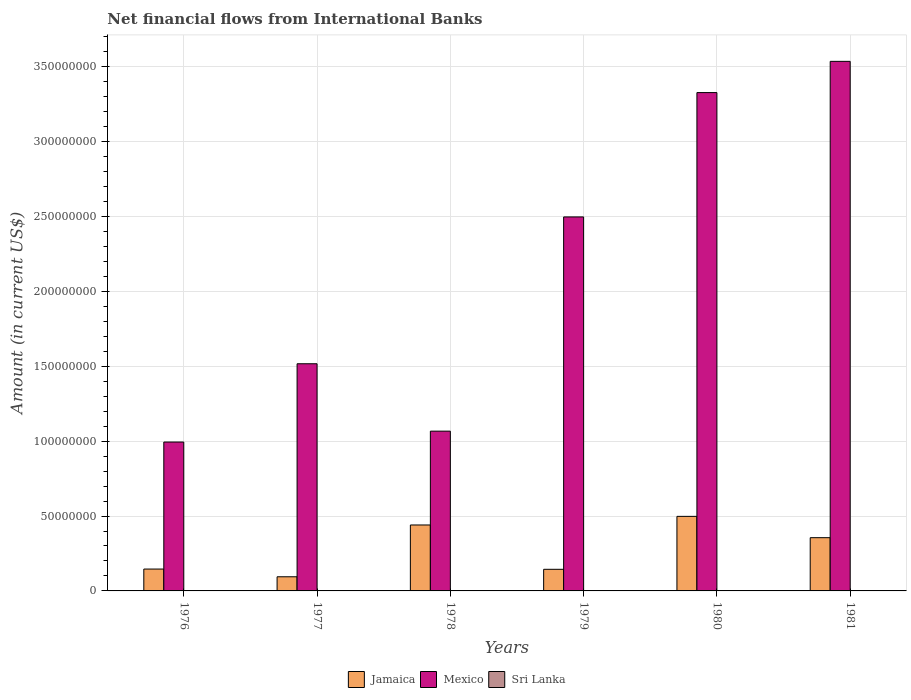How many groups of bars are there?
Make the answer very short. 6. Are the number of bars on each tick of the X-axis equal?
Keep it short and to the point. Yes. How many bars are there on the 4th tick from the right?
Offer a terse response. 2. What is the net financial aid flows in Sri Lanka in 1981?
Provide a short and direct response. 0. Across all years, what is the maximum net financial aid flows in Jamaica?
Keep it short and to the point. 4.98e+07. Across all years, what is the minimum net financial aid flows in Jamaica?
Keep it short and to the point. 9.44e+06. In which year was the net financial aid flows in Mexico maximum?
Provide a succinct answer. 1981. What is the total net financial aid flows in Mexico in the graph?
Make the answer very short. 1.29e+09. What is the difference between the net financial aid flows in Mexico in 1977 and that in 1980?
Offer a very short reply. -1.81e+08. What is the difference between the net financial aid flows in Mexico in 1976 and the net financial aid flows in Sri Lanka in 1980?
Give a very brief answer. 9.94e+07. What is the average net financial aid flows in Mexico per year?
Your answer should be very brief. 2.16e+08. In the year 1980, what is the difference between the net financial aid flows in Mexico and net financial aid flows in Jamaica?
Your answer should be compact. 2.83e+08. What is the ratio of the net financial aid flows in Mexico in 1979 to that in 1981?
Provide a short and direct response. 0.71. Is the net financial aid flows in Mexico in 1977 less than that in 1978?
Your response must be concise. No. Is the difference between the net financial aid flows in Mexico in 1977 and 1980 greater than the difference between the net financial aid flows in Jamaica in 1977 and 1980?
Ensure brevity in your answer.  No. What is the difference between the highest and the second highest net financial aid flows in Mexico?
Your response must be concise. 2.09e+07. What is the difference between the highest and the lowest net financial aid flows in Mexico?
Offer a very short reply. 2.54e+08. Is the sum of the net financial aid flows in Jamaica in 1977 and 1978 greater than the maximum net financial aid flows in Sri Lanka across all years?
Provide a succinct answer. Yes. Is it the case that in every year, the sum of the net financial aid flows in Sri Lanka and net financial aid flows in Jamaica is greater than the net financial aid flows in Mexico?
Offer a terse response. No. How many years are there in the graph?
Make the answer very short. 6. What is the difference between two consecutive major ticks on the Y-axis?
Make the answer very short. 5.00e+07. Does the graph contain any zero values?
Provide a succinct answer. Yes. Where does the legend appear in the graph?
Provide a succinct answer. Bottom center. What is the title of the graph?
Offer a terse response. Net financial flows from International Banks. Does "Congo (Democratic)" appear as one of the legend labels in the graph?
Your answer should be very brief. No. What is the Amount (in current US$) of Jamaica in 1976?
Provide a succinct answer. 1.46e+07. What is the Amount (in current US$) of Mexico in 1976?
Your answer should be compact. 9.94e+07. What is the Amount (in current US$) in Sri Lanka in 1976?
Give a very brief answer. 0. What is the Amount (in current US$) in Jamaica in 1977?
Offer a terse response. 9.44e+06. What is the Amount (in current US$) in Mexico in 1977?
Offer a very short reply. 1.52e+08. What is the Amount (in current US$) in Sri Lanka in 1977?
Your answer should be very brief. 0. What is the Amount (in current US$) of Jamaica in 1978?
Give a very brief answer. 4.40e+07. What is the Amount (in current US$) of Mexico in 1978?
Your response must be concise. 1.07e+08. What is the Amount (in current US$) of Jamaica in 1979?
Give a very brief answer. 1.44e+07. What is the Amount (in current US$) in Mexico in 1979?
Give a very brief answer. 2.50e+08. What is the Amount (in current US$) in Sri Lanka in 1979?
Provide a short and direct response. 0. What is the Amount (in current US$) of Jamaica in 1980?
Provide a short and direct response. 4.98e+07. What is the Amount (in current US$) of Mexico in 1980?
Provide a succinct answer. 3.33e+08. What is the Amount (in current US$) of Jamaica in 1981?
Give a very brief answer. 3.56e+07. What is the Amount (in current US$) in Mexico in 1981?
Give a very brief answer. 3.54e+08. What is the Amount (in current US$) of Sri Lanka in 1981?
Offer a terse response. 0. Across all years, what is the maximum Amount (in current US$) in Jamaica?
Your response must be concise. 4.98e+07. Across all years, what is the maximum Amount (in current US$) in Mexico?
Provide a short and direct response. 3.54e+08. Across all years, what is the minimum Amount (in current US$) of Jamaica?
Offer a very short reply. 9.44e+06. Across all years, what is the minimum Amount (in current US$) of Mexico?
Provide a short and direct response. 9.94e+07. What is the total Amount (in current US$) in Jamaica in the graph?
Make the answer very short. 1.68e+08. What is the total Amount (in current US$) of Mexico in the graph?
Provide a short and direct response. 1.29e+09. What is the difference between the Amount (in current US$) of Jamaica in 1976 and that in 1977?
Offer a very short reply. 5.15e+06. What is the difference between the Amount (in current US$) in Mexico in 1976 and that in 1977?
Keep it short and to the point. -5.23e+07. What is the difference between the Amount (in current US$) of Jamaica in 1976 and that in 1978?
Offer a very short reply. -2.94e+07. What is the difference between the Amount (in current US$) in Mexico in 1976 and that in 1978?
Keep it short and to the point. -7.27e+06. What is the difference between the Amount (in current US$) in Jamaica in 1976 and that in 1979?
Provide a succinct answer. 1.60e+05. What is the difference between the Amount (in current US$) of Mexico in 1976 and that in 1979?
Provide a short and direct response. -1.50e+08. What is the difference between the Amount (in current US$) of Jamaica in 1976 and that in 1980?
Provide a short and direct response. -3.52e+07. What is the difference between the Amount (in current US$) in Mexico in 1976 and that in 1980?
Your response must be concise. -2.33e+08. What is the difference between the Amount (in current US$) in Jamaica in 1976 and that in 1981?
Offer a terse response. -2.10e+07. What is the difference between the Amount (in current US$) of Mexico in 1976 and that in 1981?
Offer a very short reply. -2.54e+08. What is the difference between the Amount (in current US$) of Jamaica in 1977 and that in 1978?
Keep it short and to the point. -3.46e+07. What is the difference between the Amount (in current US$) of Mexico in 1977 and that in 1978?
Ensure brevity in your answer.  4.50e+07. What is the difference between the Amount (in current US$) in Jamaica in 1977 and that in 1979?
Make the answer very short. -4.99e+06. What is the difference between the Amount (in current US$) of Mexico in 1977 and that in 1979?
Your response must be concise. -9.80e+07. What is the difference between the Amount (in current US$) in Jamaica in 1977 and that in 1980?
Your answer should be compact. -4.03e+07. What is the difference between the Amount (in current US$) in Mexico in 1977 and that in 1980?
Provide a succinct answer. -1.81e+08. What is the difference between the Amount (in current US$) of Jamaica in 1977 and that in 1981?
Offer a very short reply. -2.61e+07. What is the difference between the Amount (in current US$) in Mexico in 1977 and that in 1981?
Give a very brief answer. -2.02e+08. What is the difference between the Amount (in current US$) of Jamaica in 1978 and that in 1979?
Offer a terse response. 2.96e+07. What is the difference between the Amount (in current US$) in Mexico in 1978 and that in 1979?
Your response must be concise. -1.43e+08. What is the difference between the Amount (in current US$) of Jamaica in 1978 and that in 1980?
Keep it short and to the point. -5.75e+06. What is the difference between the Amount (in current US$) of Mexico in 1978 and that in 1980?
Ensure brevity in your answer.  -2.26e+08. What is the difference between the Amount (in current US$) in Jamaica in 1978 and that in 1981?
Ensure brevity in your answer.  8.48e+06. What is the difference between the Amount (in current US$) of Mexico in 1978 and that in 1981?
Your answer should be very brief. -2.47e+08. What is the difference between the Amount (in current US$) in Jamaica in 1979 and that in 1980?
Provide a short and direct response. -3.53e+07. What is the difference between the Amount (in current US$) in Mexico in 1979 and that in 1980?
Provide a succinct answer. -8.30e+07. What is the difference between the Amount (in current US$) in Jamaica in 1979 and that in 1981?
Offer a terse response. -2.11e+07. What is the difference between the Amount (in current US$) in Mexico in 1979 and that in 1981?
Provide a short and direct response. -1.04e+08. What is the difference between the Amount (in current US$) of Jamaica in 1980 and that in 1981?
Provide a short and direct response. 1.42e+07. What is the difference between the Amount (in current US$) in Mexico in 1980 and that in 1981?
Provide a succinct answer. -2.09e+07. What is the difference between the Amount (in current US$) of Jamaica in 1976 and the Amount (in current US$) of Mexico in 1977?
Provide a succinct answer. -1.37e+08. What is the difference between the Amount (in current US$) of Jamaica in 1976 and the Amount (in current US$) of Mexico in 1978?
Offer a terse response. -9.21e+07. What is the difference between the Amount (in current US$) in Jamaica in 1976 and the Amount (in current US$) in Mexico in 1979?
Give a very brief answer. -2.35e+08. What is the difference between the Amount (in current US$) of Jamaica in 1976 and the Amount (in current US$) of Mexico in 1980?
Provide a short and direct response. -3.18e+08. What is the difference between the Amount (in current US$) in Jamaica in 1976 and the Amount (in current US$) in Mexico in 1981?
Offer a very short reply. -3.39e+08. What is the difference between the Amount (in current US$) of Jamaica in 1977 and the Amount (in current US$) of Mexico in 1978?
Your answer should be compact. -9.72e+07. What is the difference between the Amount (in current US$) in Jamaica in 1977 and the Amount (in current US$) in Mexico in 1979?
Keep it short and to the point. -2.40e+08. What is the difference between the Amount (in current US$) of Jamaica in 1977 and the Amount (in current US$) of Mexico in 1980?
Offer a terse response. -3.23e+08. What is the difference between the Amount (in current US$) of Jamaica in 1977 and the Amount (in current US$) of Mexico in 1981?
Offer a very short reply. -3.44e+08. What is the difference between the Amount (in current US$) of Jamaica in 1978 and the Amount (in current US$) of Mexico in 1979?
Give a very brief answer. -2.06e+08. What is the difference between the Amount (in current US$) of Jamaica in 1978 and the Amount (in current US$) of Mexico in 1980?
Offer a very short reply. -2.89e+08. What is the difference between the Amount (in current US$) in Jamaica in 1978 and the Amount (in current US$) in Mexico in 1981?
Your response must be concise. -3.10e+08. What is the difference between the Amount (in current US$) of Jamaica in 1979 and the Amount (in current US$) of Mexico in 1980?
Give a very brief answer. -3.18e+08. What is the difference between the Amount (in current US$) of Jamaica in 1979 and the Amount (in current US$) of Mexico in 1981?
Keep it short and to the point. -3.39e+08. What is the difference between the Amount (in current US$) of Jamaica in 1980 and the Amount (in current US$) of Mexico in 1981?
Give a very brief answer. -3.04e+08. What is the average Amount (in current US$) of Jamaica per year?
Give a very brief answer. 2.80e+07. What is the average Amount (in current US$) in Mexico per year?
Offer a terse response. 2.16e+08. In the year 1976, what is the difference between the Amount (in current US$) of Jamaica and Amount (in current US$) of Mexico?
Give a very brief answer. -8.48e+07. In the year 1977, what is the difference between the Amount (in current US$) of Jamaica and Amount (in current US$) of Mexico?
Ensure brevity in your answer.  -1.42e+08. In the year 1978, what is the difference between the Amount (in current US$) in Jamaica and Amount (in current US$) in Mexico?
Your response must be concise. -6.27e+07. In the year 1979, what is the difference between the Amount (in current US$) of Jamaica and Amount (in current US$) of Mexico?
Offer a terse response. -2.35e+08. In the year 1980, what is the difference between the Amount (in current US$) in Jamaica and Amount (in current US$) in Mexico?
Offer a terse response. -2.83e+08. In the year 1981, what is the difference between the Amount (in current US$) of Jamaica and Amount (in current US$) of Mexico?
Your answer should be compact. -3.18e+08. What is the ratio of the Amount (in current US$) in Jamaica in 1976 to that in 1977?
Ensure brevity in your answer.  1.55. What is the ratio of the Amount (in current US$) of Mexico in 1976 to that in 1977?
Keep it short and to the point. 0.66. What is the ratio of the Amount (in current US$) of Jamaica in 1976 to that in 1978?
Offer a very short reply. 0.33. What is the ratio of the Amount (in current US$) of Mexico in 1976 to that in 1978?
Provide a succinct answer. 0.93. What is the ratio of the Amount (in current US$) in Jamaica in 1976 to that in 1979?
Offer a very short reply. 1.01. What is the ratio of the Amount (in current US$) in Mexico in 1976 to that in 1979?
Your response must be concise. 0.4. What is the ratio of the Amount (in current US$) in Jamaica in 1976 to that in 1980?
Offer a very short reply. 0.29. What is the ratio of the Amount (in current US$) of Mexico in 1976 to that in 1980?
Provide a short and direct response. 0.3. What is the ratio of the Amount (in current US$) in Jamaica in 1976 to that in 1981?
Offer a very short reply. 0.41. What is the ratio of the Amount (in current US$) in Mexico in 1976 to that in 1981?
Keep it short and to the point. 0.28. What is the ratio of the Amount (in current US$) in Jamaica in 1977 to that in 1978?
Offer a terse response. 0.21. What is the ratio of the Amount (in current US$) in Mexico in 1977 to that in 1978?
Ensure brevity in your answer.  1.42. What is the ratio of the Amount (in current US$) of Jamaica in 1977 to that in 1979?
Keep it short and to the point. 0.65. What is the ratio of the Amount (in current US$) of Mexico in 1977 to that in 1979?
Your response must be concise. 0.61. What is the ratio of the Amount (in current US$) of Jamaica in 1977 to that in 1980?
Offer a terse response. 0.19. What is the ratio of the Amount (in current US$) of Mexico in 1977 to that in 1980?
Offer a terse response. 0.46. What is the ratio of the Amount (in current US$) in Jamaica in 1977 to that in 1981?
Provide a succinct answer. 0.27. What is the ratio of the Amount (in current US$) in Mexico in 1977 to that in 1981?
Offer a very short reply. 0.43. What is the ratio of the Amount (in current US$) of Jamaica in 1978 to that in 1979?
Make the answer very short. 3.05. What is the ratio of the Amount (in current US$) of Mexico in 1978 to that in 1979?
Ensure brevity in your answer.  0.43. What is the ratio of the Amount (in current US$) in Jamaica in 1978 to that in 1980?
Give a very brief answer. 0.88. What is the ratio of the Amount (in current US$) of Mexico in 1978 to that in 1980?
Ensure brevity in your answer.  0.32. What is the ratio of the Amount (in current US$) in Jamaica in 1978 to that in 1981?
Provide a succinct answer. 1.24. What is the ratio of the Amount (in current US$) in Mexico in 1978 to that in 1981?
Your answer should be compact. 0.3. What is the ratio of the Amount (in current US$) in Jamaica in 1979 to that in 1980?
Provide a succinct answer. 0.29. What is the ratio of the Amount (in current US$) of Mexico in 1979 to that in 1980?
Your answer should be compact. 0.75. What is the ratio of the Amount (in current US$) in Jamaica in 1979 to that in 1981?
Ensure brevity in your answer.  0.41. What is the ratio of the Amount (in current US$) in Mexico in 1979 to that in 1981?
Make the answer very short. 0.71. What is the ratio of the Amount (in current US$) of Jamaica in 1980 to that in 1981?
Provide a succinct answer. 1.4. What is the ratio of the Amount (in current US$) of Mexico in 1980 to that in 1981?
Provide a succinct answer. 0.94. What is the difference between the highest and the second highest Amount (in current US$) of Jamaica?
Your answer should be very brief. 5.75e+06. What is the difference between the highest and the second highest Amount (in current US$) of Mexico?
Offer a terse response. 2.09e+07. What is the difference between the highest and the lowest Amount (in current US$) of Jamaica?
Keep it short and to the point. 4.03e+07. What is the difference between the highest and the lowest Amount (in current US$) of Mexico?
Provide a short and direct response. 2.54e+08. 